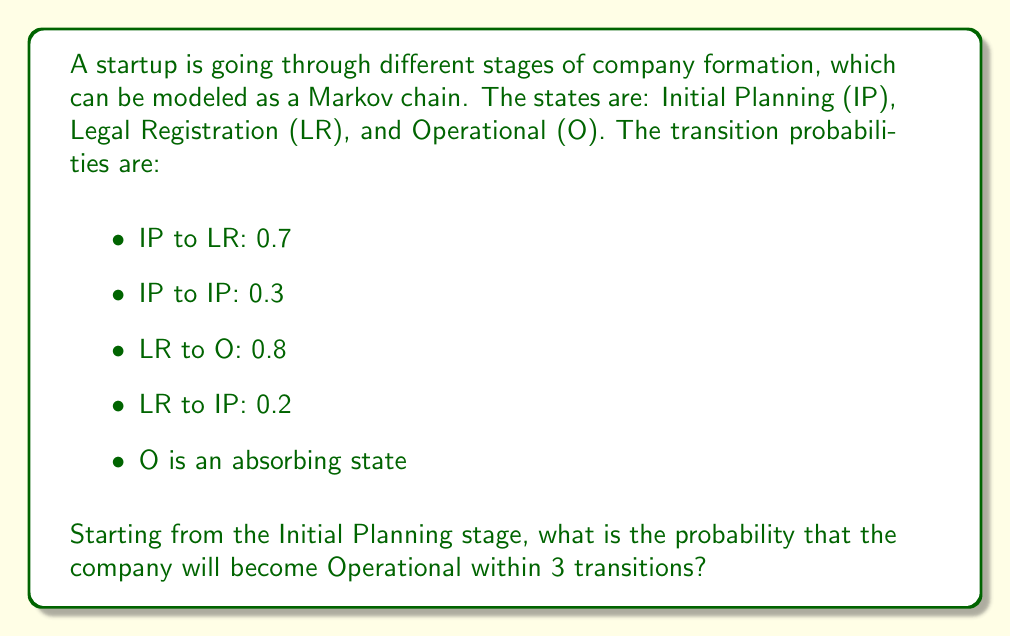Help me with this question. To solve this problem, we'll use the Markov chain transition matrix and calculate the probabilities for each step:

1. Define the transition matrix P:
   $$P = \begin{bmatrix}
   0.3 & 0.7 & 0 \\
   0.2 & 0 & 0.8 \\
   0 & 0 & 1
   \end{bmatrix}$$

2. Calculate $P^2$ and $P^3$:
   $$P^2 = \begin{bmatrix}
   0.23 & 0.21 & 0.56 \\
   0.06 & 0.14 & 0.80 \\
   0 & 0 & 1
   \end{bmatrix}$$
   
   $$P^3 = \begin{bmatrix}
   0.089 & 0.133 & 0.778 \\
   0.046 & 0.042 & 0.912 \\
   0 & 0 & 1
   \end{bmatrix}$$

3. Starting from IP (initial state vector $[1, 0, 0]$), the probability of reaching O in:
   - 1 step: 0
   - 2 steps: 0.56
   - 3 steps: 0.778

4. The total probability of reaching O within 3 transitions is the sum of these probabilities:
   $$P(\text{O within 3 steps}) = 0 + 0.56 + 0.778 = 0.778$$
Answer: 0.778 